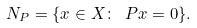Convert formula to latex. <formula><loc_0><loc_0><loc_500><loc_500>N _ { P } = \{ x \in X \colon \ P x = 0 \} .</formula> 